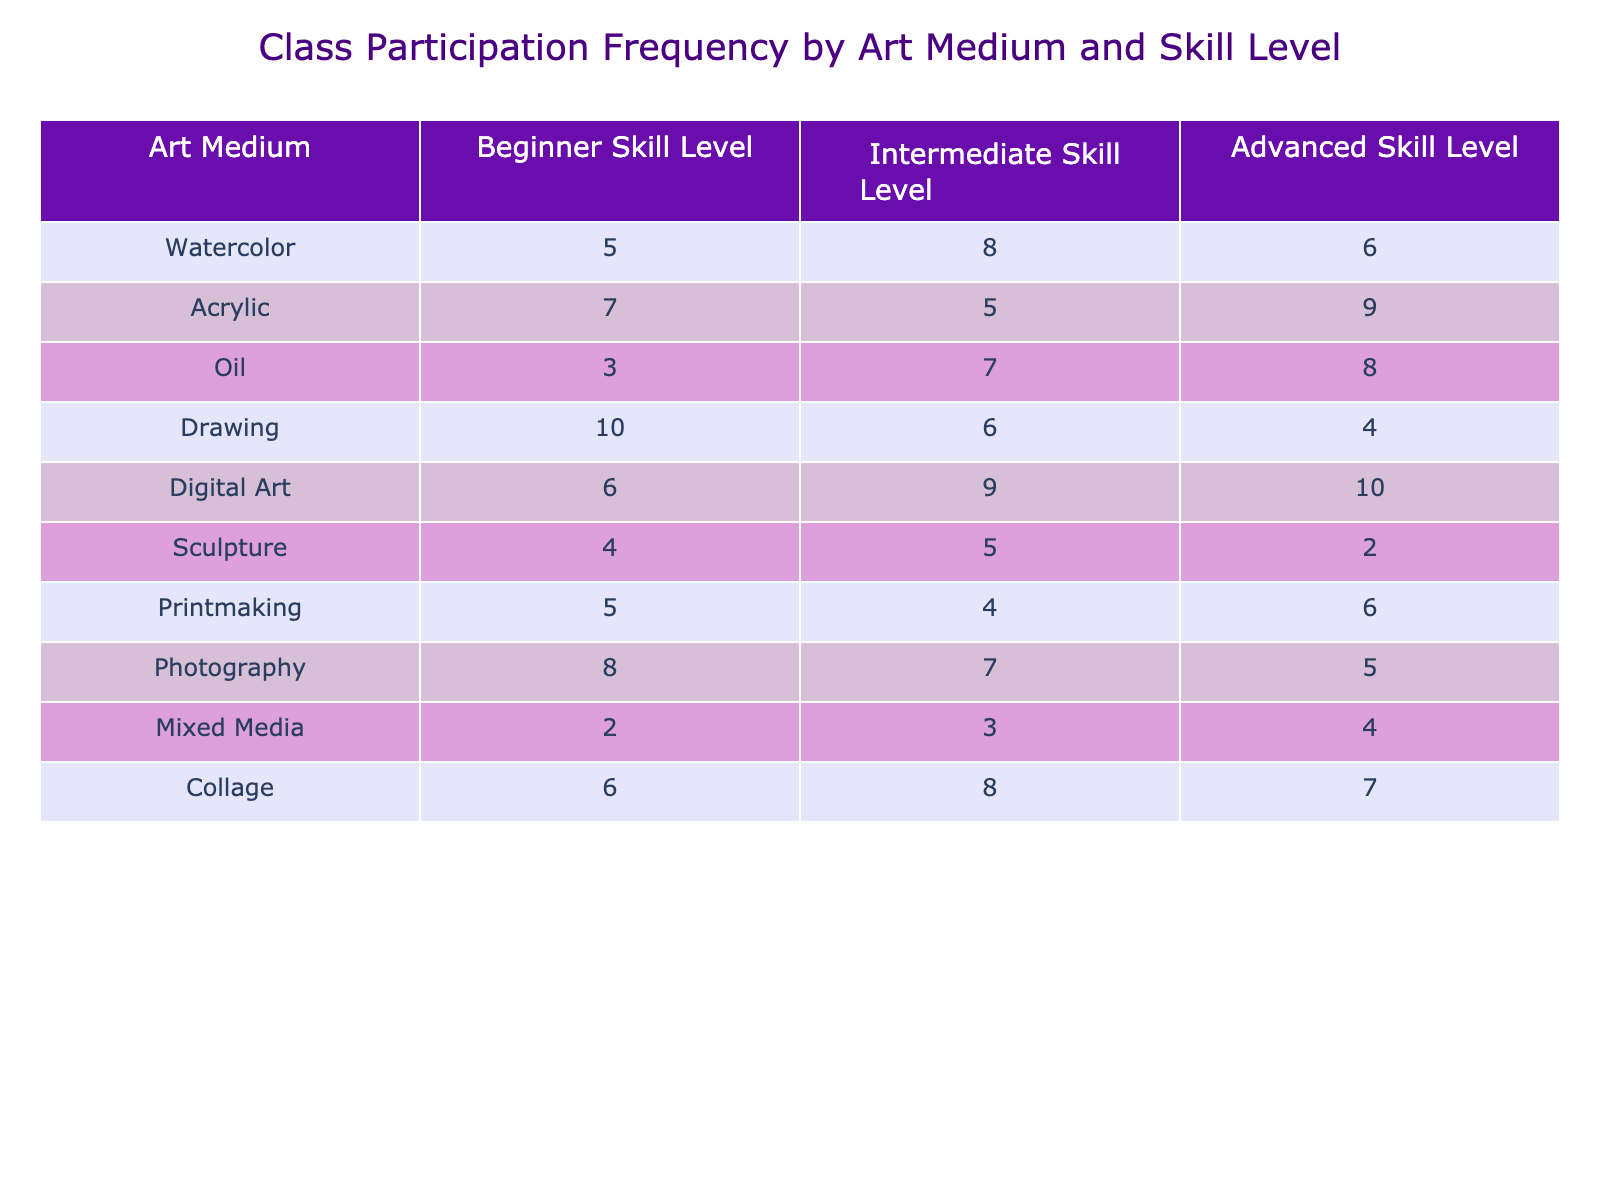What is the highest participation frequency for beginners? To find the highest participation frequency for beginners, we look through the "Beginner Skill Level" column. The highest value here is 10 from the "Drawing" row.
Answer: 10 Which art medium has the lowest total participation frequency across all skill levels? First, we need to sum the participation frequencies for each medium: Watercolor (19), Acrylic (21), Oil (18), Drawing (20), Digital Art (25), Sculpture (11), Printmaking (15), Photography (20), Mixed Media (9), Collage (21). The lowest total is for "Mixed Media" with a sum of 9.
Answer: Mixed Media Is the participation frequency for advanced skill level in Digital Art greater than that in Acrylic? The participation frequency for advanced skill level in Digital Art is 10, while in Acrylic it is 9. Since 10 is greater than 9, the statement is true.
Answer: Yes What is the difference in participation frequency between beginner and advanced levels for Oil? To find the difference, we subtract the advanced frequency (8) from the beginner frequency (3). This gives us a difference of 3 - 8 = -5. So, the advanced level has a higher participation. The absolute difference is 5.
Answer: 5 Which skill level has the highest overall total participation frequency? We calculate the sum of participation frequencies for each skill level: Beginner (63), Intermediate (65), Advanced (66). The highest total is for the advanced skill level with a sum of 66.
Answer: Advanced How many students participated in Sculpture at the beginner skill level? From the table, the participation frequency for Sculpture at the beginner skill level is 4.
Answer: 4 If you combine the participation frequency of Drawing and Acrylic at the intermediate skill level, what do you get? For Drawing, the participation frequency at intermediate is 6, and for Acrylic, it is 5. Summing these together gives 6 + 5 = 11.
Answer: 11 Is there a higher participation frequency for Collage in the beginner level compared to Sculpture in the intermediate level? The participation frequency for Collage at the beginner level is 6, and for Sculpture at the intermediate level, it is 5. Since 6 is greater than 5, the statement is true.
Answer: Yes What is the average participation frequency across all skill levels for Photography? The participation frequencies for Photography are: 8 (Beginner), 7 (Intermediate), and 5 (Advanced). Summing these gives 8 + 7 + 5 = 20. Since there are 3 values, we divide: 20 / 3 = approximately 6.67.
Answer: 6.67 